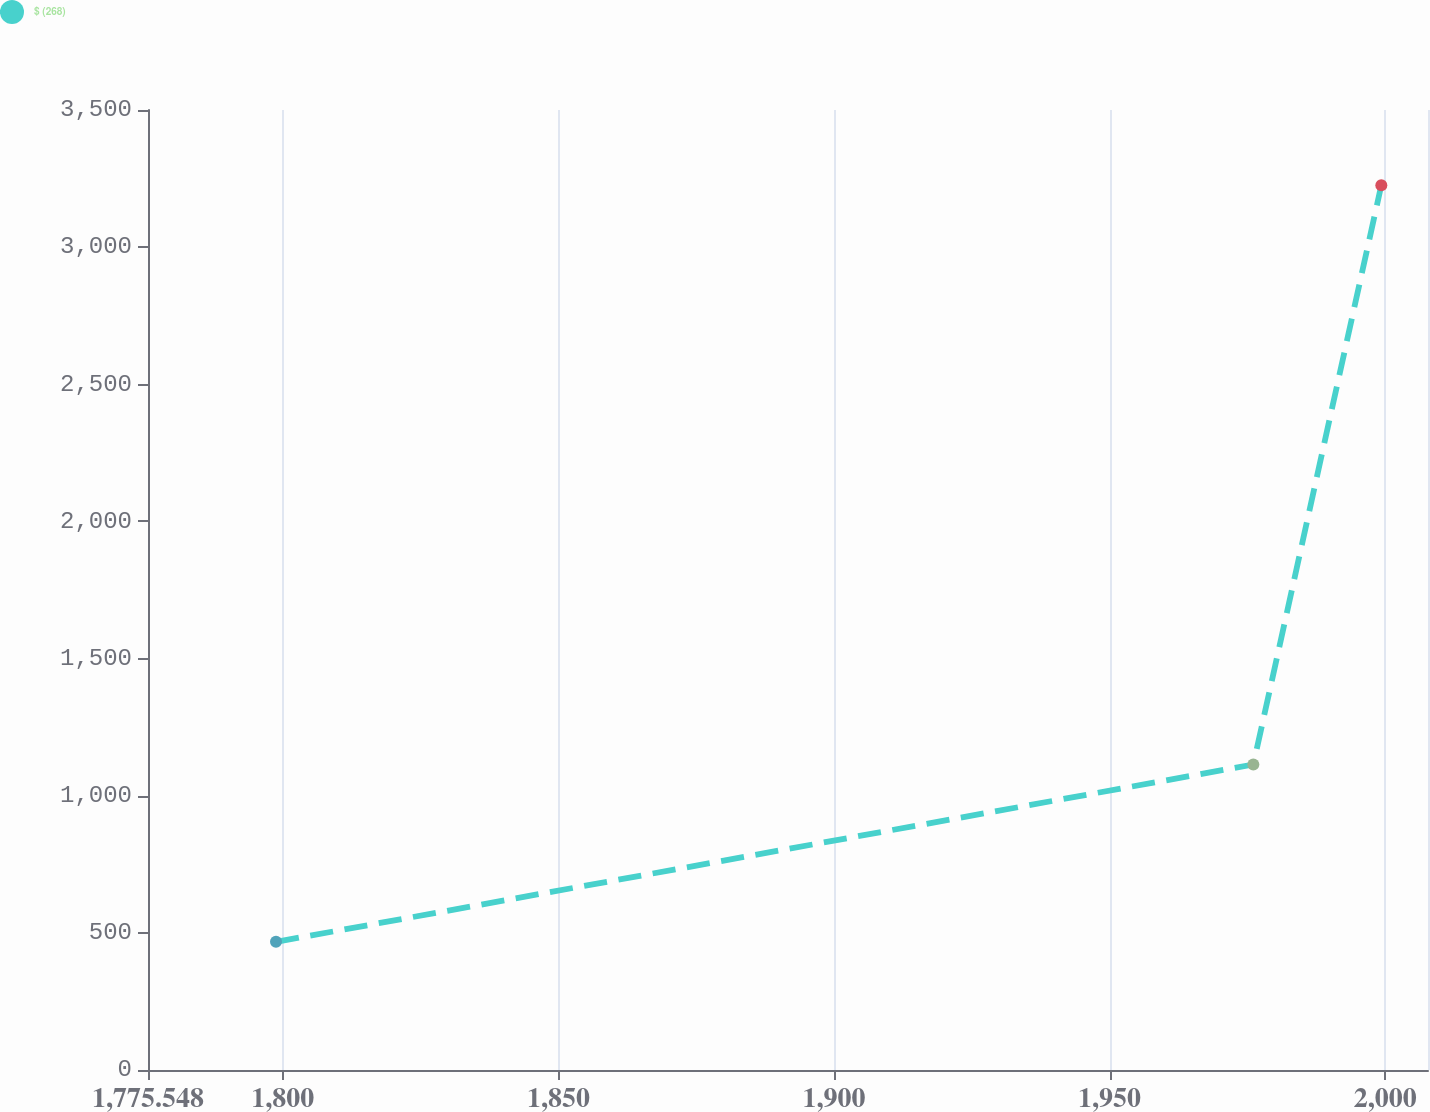<chart> <loc_0><loc_0><loc_500><loc_500><line_chart><ecel><fcel>$ (268)<nl><fcel>1798.77<fcel>467.15<nl><fcel>1976.08<fcel>1113.81<nl><fcel>1999.3<fcel>3226.01<nl><fcel>2030.99<fcel>2833.81<nl></chart> 